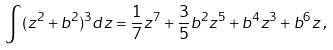<formula> <loc_0><loc_0><loc_500><loc_500>\int ( z ^ { 2 } + b ^ { 2 } ) ^ { 3 } d z = \frac { 1 } { 7 } z ^ { 7 } + \frac { 3 } { 5 } b ^ { 2 } z ^ { 5 } + b ^ { 4 } z ^ { 3 } + b ^ { 6 } z \, ,</formula> 